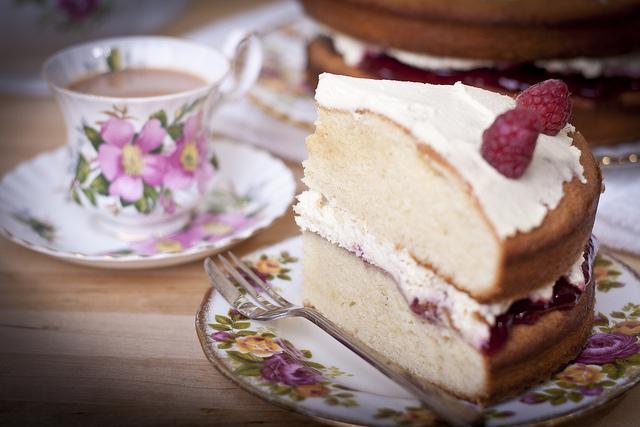How many cakes are there?
Give a very brief answer. 1. 